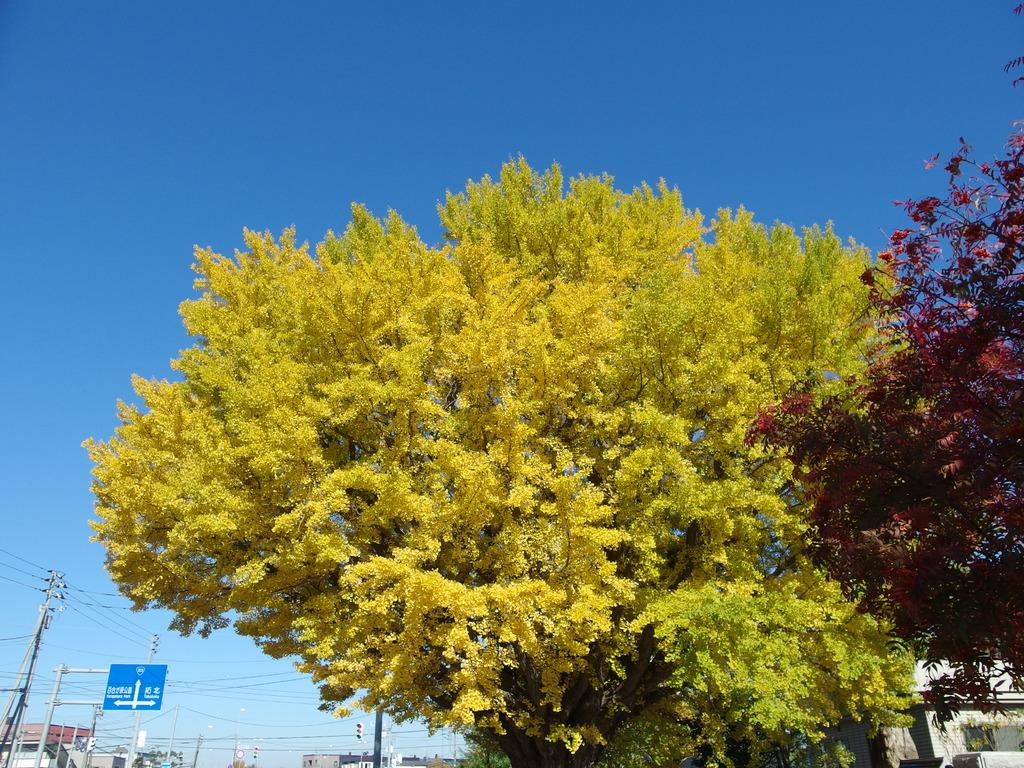What type of natural elements can be seen in the image? There are trees in the image. What type of man-made structures are present in the image? There are buildings in the image. What other objects can be seen in the image? There are poles in the image. What is attached to one of the poles in the image? There is a sign board on a pole in the image. What is the color of the sky in the image? The sky is blue in the image. Where is the jail located in the image? There is no jail present in the image. Which direction is north in the image? The image does not provide any information about the direction of north. How many legs are visible in the image? There are no legs visible in the image. 